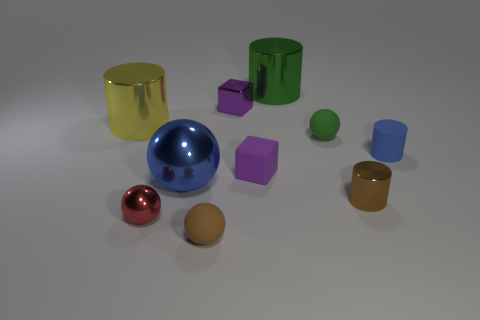Subtract 2 spheres. How many spheres are left? 2 Subtract all small metallic spheres. How many spheres are left? 3 Subtract all brown cylinders. How many cylinders are left? 3 Subtract all balls. How many objects are left? 6 Subtract all gray balls. Subtract all cyan cylinders. How many balls are left? 4 Subtract all small blue objects. Subtract all blue shiny spheres. How many objects are left? 8 Add 8 purple rubber things. How many purple rubber things are left? 9 Add 7 large blue metal cylinders. How many large blue metal cylinders exist? 7 Subtract 0 yellow cubes. How many objects are left? 10 